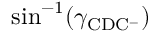Convert formula to latex. <formula><loc_0><loc_0><loc_500><loc_500>\sin ^ { - 1 } ( \gamma _ { C D C ^ { - } } )</formula> 